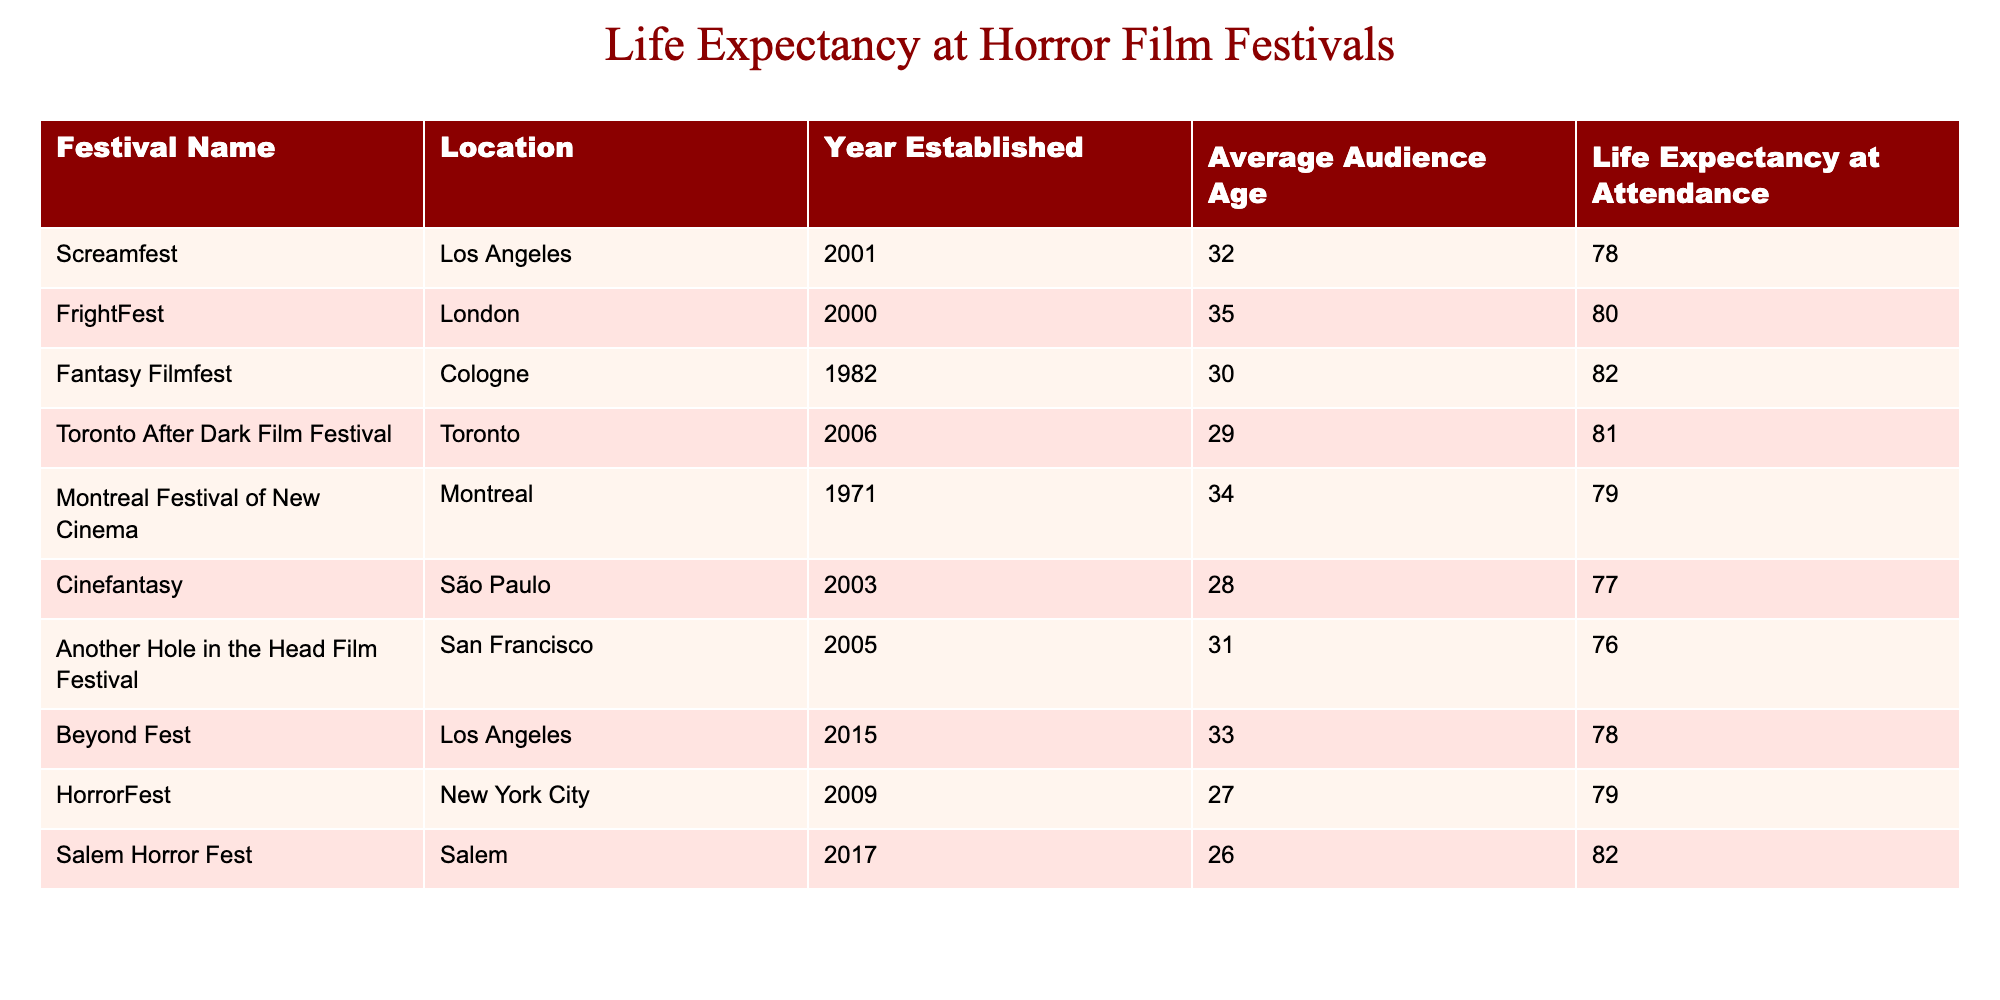What is the life expectancy at the Screamfest festival? By locating the row that pertains to Screamfest in the table, I see that its life expectancy at attendance is listed in the corresponding column. This value is 78.
Answer: 78 Which festival has the highest average audience age? I need to review the average audience age column for all festivals. Upon examination, FrightFest has the highest average audience age of 35.
Answer: FrightFest What is the average life expectancy of attendees at horror film festivals in Salem and Montreal? I first identify life expectancy values from both Salem Horror Fest (82) and Montreal Festival of New Cinema (79). Adding these together gives 161, and dividing by 2 (the number of festivals) yields an average of 80.5.
Answer: 80.5 Are there any festivals where the life expectancy is below 80? I review the life expectancy column and see that both Cinefantasy and Another Hole in the Head Film Festival have values of 77 and 76, respectively, which are below 80. Therefore, the answer is yes.
Answer: Yes What is the difference in life expectancy between the oldest festival and the newest festival? I first locate the oldest festival, which is Fantasy Filmfest established in 1982, with a life expectancy of 82. Then I look at the newest festival, Beyond Fest established in 2015, with a life expectancy of 78. The difference between these two values is 82 - 78 = 4.
Answer: 4 How many festivals have a life expectancy of 79 or lower? By checking the life expectancy column, I see that there are three festivals: Another Hole in the Head Film Festival (76), Cinefantasy (77), and HorrorFest (79). Counting these gives a total of 3.
Answer: 3 Which location has the lowest life expectancy at a horror film festival? I review the life expectancy values across all festivals and find that the location with the lowest life expectancy is São Paulo at the Cinefantasy festival, which is 77.
Answer: São Paulo What is the cumulative life expectancy of audiences from all festivals listed? I sum the life expectancy values from all entries: 78 + 80 + 82 + 81 + 79 + 77 + 76 + 78 + 79 + 82 = 793. This total represents the cumulative life expectancy. Thus, the cumulative life expectancy is 793.
Answer: 793 